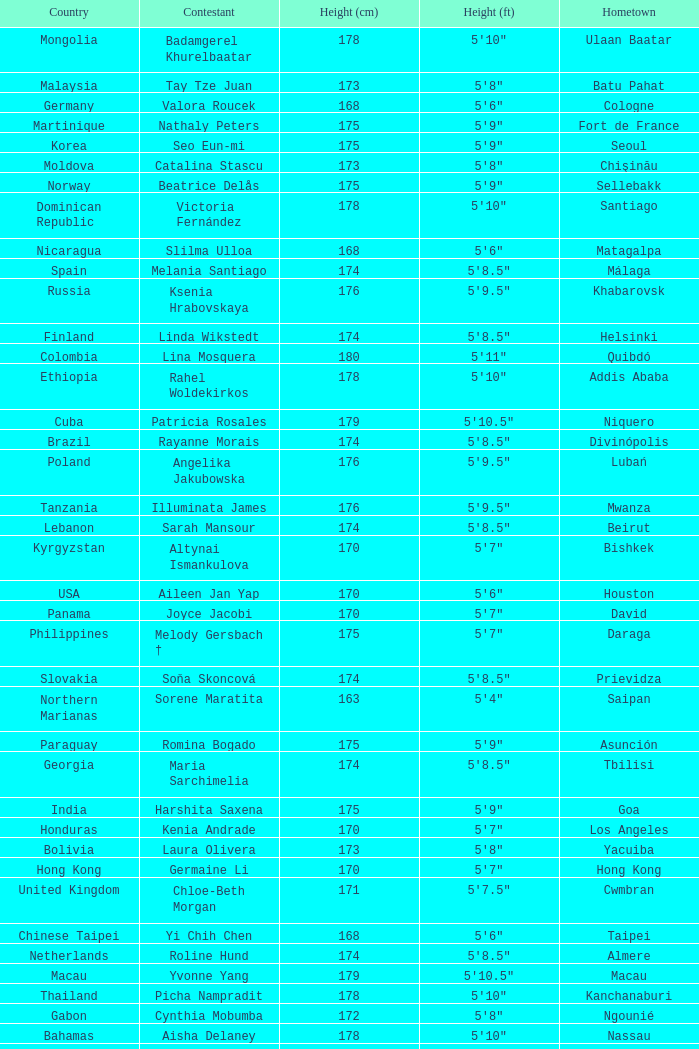Write the full table. {'header': ['Country', 'Contestant', 'Height (cm)', 'Height (ft)', 'Hometown'], 'rows': [['Mongolia', 'Badamgerel Khurelbaatar', '178', '5\'10"', 'Ulaan Baatar'], ['Malaysia', 'Tay Tze Juan', '173', '5\'8"', 'Batu Pahat'], ['Germany', 'Valora Roucek', '168', '5\'6"', 'Cologne'], ['Martinique', 'Nathaly Peters', '175', '5\'9"', 'Fort de France'], ['Korea', 'Seo Eun-mi', '175', '5\'9"', 'Seoul'], ['Moldova', 'Catalina Stascu', '173', '5\'8"', 'Chişinău'], ['Norway', 'Beatrice Delås', '175', '5\'9"', 'Sellebakk'], ['Dominican Republic', 'Victoria Fernández', '178', '5\'10"', 'Santiago'], ['Nicaragua', 'Slilma Ulloa', '168', '5\'6"', 'Matagalpa'], ['Spain', 'Melania Santiago', '174', '5\'8.5"', 'Málaga'], ['Russia', 'Ksenia Hrabovskaya', '176', '5\'9.5"', 'Khabarovsk'], ['Finland', 'Linda Wikstedt', '174', '5\'8.5"', 'Helsinki'], ['Colombia', 'Lina Mosquera', '180', '5\'11"', 'Quibdó'], ['Ethiopia', 'Rahel Woldekirkos', '178', '5\'10"', 'Addis Ababa'], ['Cuba', 'Patricia Rosales', '179', '5\'10.5"', 'Niquero'], ['Brazil', 'Rayanne Morais', '174', '5\'8.5"', 'Divinópolis'], ['Poland', 'Angelika Jakubowska', '176', '5\'9.5"', 'Lubań'], ['Tanzania', 'Illuminata James', '176', '5\'9.5"', 'Mwanza'], ['Lebanon', 'Sarah Mansour', '174', '5\'8.5"', 'Beirut'], ['Kyrgyzstan', 'Altynai Ismankulova', '170', '5\'7"', 'Bishkek'], ['USA', 'Aileen Jan Yap', '170', '5\'6"', 'Houston'], ['Panama', 'Joyce Jacobi', '170', '5\'7"', 'David'], ['Philippines', 'Melody Gersbach †', '175', '5\'7"', 'Daraga'], ['Slovakia', 'Soňa Skoncová', '174', '5\'8.5"', 'Prievidza'], ['Northern Marianas', 'Sorene Maratita', '163', '5\'4"', 'Saipan'], ['Paraguay', 'Romina Bogado', '175', '5\'9"', 'Asunción'], ['Georgia', 'Maria Sarchimelia', '174', '5\'8.5"', 'Tbilisi'], ['India', 'Harshita Saxena', '175', '5\'9"', 'Goa'], ['Honduras', 'Kenia Andrade', '170', '5\'7"', 'Los Angeles'], ['Bolivia', 'Laura Olivera', '173', '5\'8"', 'Yacuiba'], ['Hong Kong', 'Germaine Li', '170', '5\'7"', 'Hong Kong'], ['United Kingdom', 'Chloe-Beth Morgan', '171', '5\'7.5"', 'Cwmbran'], ['Chinese Taipei', 'Yi Chih Chen', '168', '5\'6"', 'Taipei'], ['Netherlands', 'Roline Hund', '174', '5\'8.5"', 'Almere'], ['Macau', 'Yvonne Yang', '179', '5\'10.5"', 'Macau'], ['Thailand', 'Picha Nampradit', '178', '5\'10"', 'Kanchanaburi'], ['Gabon', 'Cynthia Mobumba', '172', '5\'8"', 'Ngounié'], ['Bahamas', 'Aisha Delaney', '178', '5\'10"', 'Nassau'], ['Guadeloupe', 'Joelle Clamy', '184', '6\'0.5"', 'Petit-Canal'], ['China', 'Wang Qian', '171', '5\'7.5"', 'Chengdu'], ['El Salvador', 'Vanessa Hueck', '178', '5\'10"', 'San Salvador'], ['Venezuela', 'Laksmi Rodríguez', '178', '5\'10"', 'Caracas'], ['Uganda', 'Pierra Akwero', '177', '5\'9.5"', 'Entebbe'], ['Romania', 'Iuliana Capsuc', '174', '5\'8.5"', 'Bucharest'], ['Ecuador', 'Isabella Chiriboga', '174', '5\'8.5"', 'Quito'], ['Puerto Rico', 'Mónica Pastrana', '178', '5\'10"', 'Manatí'], ['Sudan', 'Suna William', '168', '5\'6"', 'Darfur'], ['Aruba', 'Christina Trejo', '175', '5\'9"', 'Companashi'], ['Indonesia', 'Ayu Diandra Sari', '175', '5\'9"', 'Denpasar'], ['Singapore', 'Annabelle Liang', '169', '5\'6.5"', 'Singapore'], ['Belarus', 'Yana Supranovich', '180', '5\'11"', 'Minsk'], ['Czech Republic', 'Darja Jacukevičová', '180', '5\'11"', 'Veselí nad Moravou'], ['Japan', 'Yuka Nakayama', '173', '5\'8"', 'Fukuoka'], ['Mexico', 'Anagabriela Espinoza', '180', '5\'11"', 'Monterrey'], ['Peru', 'Alejandra Pezet', '176', '5\'9.5"', 'Lima'], ['Vietnam', 'Trần Thị Quỳnh', '175', '5\'9"', 'Hai Phong'], ['Canada', 'Chanel Beckenlehner', '173', '5\'8"', 'Toronto'], ['Turkey', 'Begüm Yılmaz', '180', '5\'11"', 'Izmir'], ['Australia', 'Kelly Louise Macguire', '174', '5\'8.5"', 'Sydney'], ['Argentina', 'María Mercedes Viaña', '174', '5\'8.5"', 'Santiago del Estero'], ['South Africa', 'Bokang Montjane', '174', '5\'8.5"', 'Johannesburg'], ['France', 'Mathilde Muller', '176', '5\'9.5"', 'Valence'], ['Greece', 'Diana Igropoulou', '177', '5\'9.5"', 'Athens'], ['Belgium', "Cassandra D'Ermilio", '175', '5\'9"', 'Quaregnon'], ['Latvia', 'Anda Pudule', '173', '5\'8"', 'Riga']]} What is the hometown of the player from Indonesia? Denpasar. 